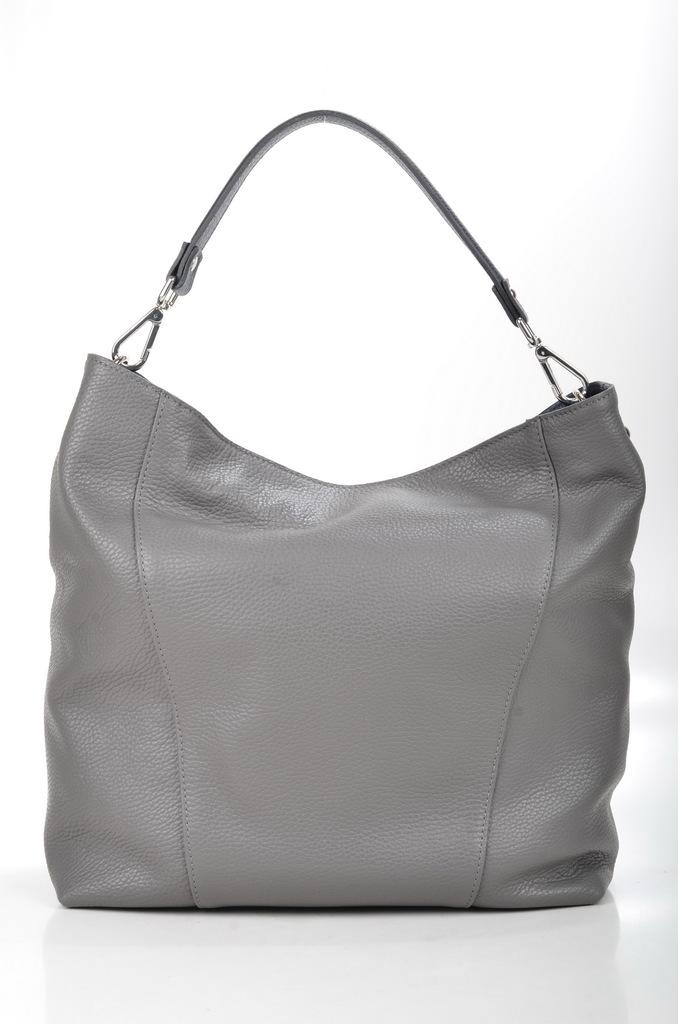What color is the handbag in the image? The handbag is grey in color. Where is the handbag located in the image? The handbag is placed on a white table. How can the handbag be carried? The handbag has a single handle for carrying. What type of insect can be seen crawling on the handbag in the image? There are no insects present on the handbag in the image. 